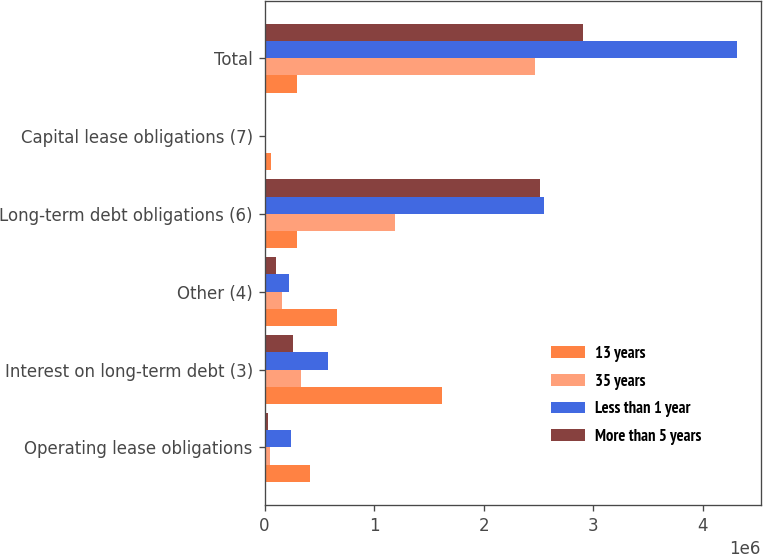<chart> <loc_0><loc_0><loc_500><loc_500><stacked_bar_chart><ecel><fcel>Operating lease obligations<fcel>Interest on long-term debt (3)<fcel>Other (4)<fcel>Long-term debt obligations (6)<fcel>Capital lease obligations (7)<fcel>Total<nl><fcel>13 years<fcel>418250<fcel>1.6169e+06<fcel>660705<fcel>295529<fcel>58646<fcel>295529<nl><fcel>35 years<fcel>53688<fcel>335689<fcel>159255<fcel>1.19048e+06<fcel>8452<fcel>2.47267e+06<nl><fcel>Less than 1 year<fcel>240359<fcel>578546<fcel>227711<fcel>2.55277e+06<fcel>12332<fcel>4.31529e+06<nl><fcel>More than 5 years<fcel>28354<fcel>255369<fcel>106597<fcel>2.51208e+06<fcel>4107<fcel>2.9065e+06<nl></chart> 